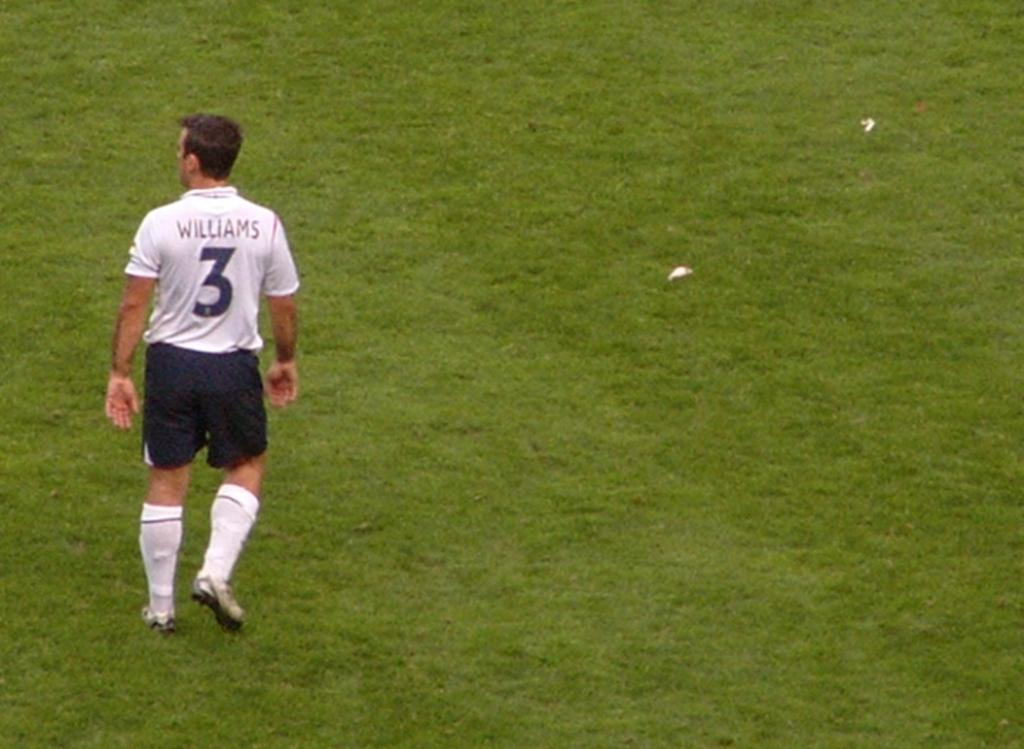<image>
Render a clear and concise summary of the photo. A player whose name on the jersey is Williams 